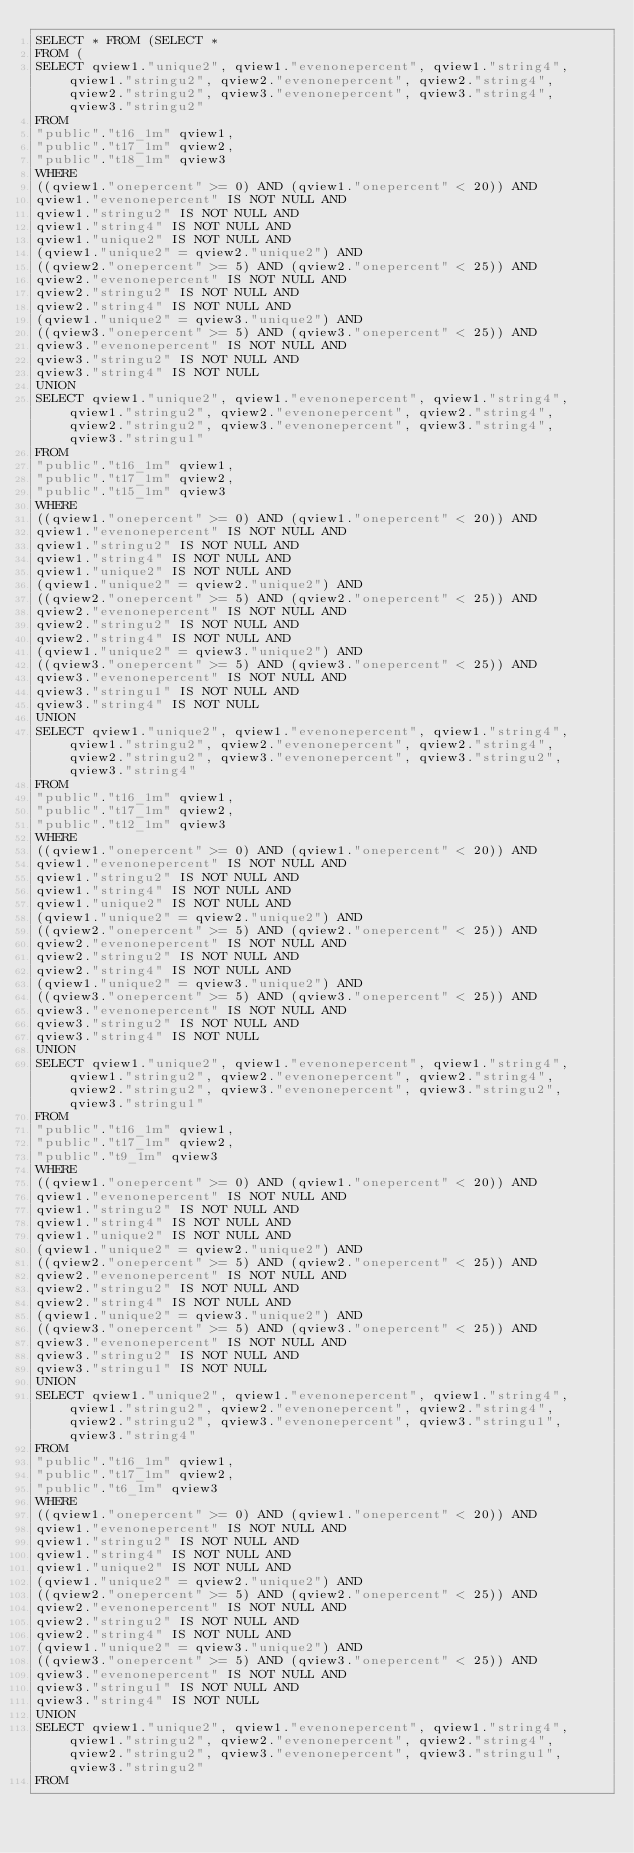Convert code to text. <code><loc_0><loc_0><loc_500><loc_500><_SQL_>SELECT * FROM (SELECT *
FROM (
SELECT qview1."unique2", qview1."evenonepercent", qview1."string4", qview1."stringu2", qview2."evenonepercent", qview2."string4", qview2."stringu2", qview3."evenonepercent", qview3."string4", qview3."stringu2"
FROM
"public"."t16_1m" qview1,
"public"."t17_1m" qview2,
"public"."t18_1m" qview3
WHERE
((qview1."onepercent" >= 0) AND (qview1."onepercent" < 20)) AND
qview1."evenonepercent" IS NOT NULL AND
qview1."stringu2" IS NOT NULL AND
qview1."string4" IS NOT NULL AND
qview1."unique2" IS NOT NULL AND
(qview1."unique2" = qview2."unique2") AND
((qview2."onepercent" >= 5) AND (qview2."onepercent" < 25)) AND
qview2."evenonepercent" IS NOT NULL AND
qview2."stringu2" IS NOT NULL AND
qview2."string4" IS NOT NULL AND
(qview1."unique2" = qview3."unique2") AND
((qview3."onepercent" >= 5) AND (qview3."onepercent" < 25)) AND
qview3."evenonepercent" IS NOT NULL AND
qview3."stringu2" IS NOT NULL AND
qview3."string4" IS NOT NULL
UNION
SELECT qview1."unique2", qview1."evenonepercent", qview1."string4", qview1."stringu2", qview2."evenonepercent", qview2."string4", qview2."stringu2", qview3."evenonepercent", qview3."string4", qview3."stringu1"
FROM
"public"."t16_1m" qview1,
"public"."t17_1m" qview2,
"public"."t15_1m" qview3
WHERE
((qview1."onepercent" >= 0) AND (qview1."onepercent" < 20)) AND
qview1."evenonepercent" IS NOT NULL AND
qview1."stringu2" IS NOT NULL AND
qview1."string4" IS NOT NULL AND
qview1."unique2" IS NOT NULL AND
(qview1."unique2" = qview2."unique2") AND
((qview2."onepercent" >= 5) AND (qview2."onepercent" < 25)) AND
qview2."evenonepercent" IS NOT NULL AND
qview2."stringu2" IS NOT NULL AND
qview2."string4" IS NOT NULL AND
(qview1."unique2" = qview3."unique2") AND
((qview3."onepercent" >= 5) AND (qview3."onepercent" < 25)) AND
qview3."evenonepercent" IS NOT NULL AND
qview3."stringu1" IS NOT NULL AND
qview3."string4" IS NOT NULL
UNION
SELECT qview1."unique2", qview1."evenonepercent", qview1."string4", qview1."stringu2", qview2."evenonepercent", qview2."string4", qview2."stringu2", qview3."evenonepercent", qview3."stringu2", qview3."string4"
FROM
"public"."t16_1m" qview1,
"public"."t17_1m" qview2,
"public"."t12_1m" qview3
WHERE
((qview1."onepercent" >= 0) AND (qview1."onepercent" < 20)) AND
qview1."evenonepercent" IS NOT NULL AND
qview1."stringu2" IS NOT NULL AND
qview1."string4" IS NOT NULL AND
qview1."unique2" IS NOT NULL AND
(qview1."unique2" = qview2."unique2") AND
((qview2."onepercent" >= 5) AND (qview2."onepercent" < 25)) AND
qview2."evenonepercent" IS NOT NULL AND
qview2."stringu2" IS NOT NULL AND
qview2."string4" IS NOT NULL AND
(qview1."unique2" = qview3."unique2") AND
((qview3."onepercent" >= 5) AND (qview3."onepercent" < 25)) AND
qview3."evenonepercent" IS NOT NULL AND
qview3."stringu2" IS NOT NULL AND
qview3."string4" IS NOT NULL
UNION
SELECT qview1."unique2", qview1."evenonepercent", qview1."string4", qview1."stringu2", qview2."evenonepercent", qview2."string4", qview2."stringu2", qview3."evenonepercent", qview3."stringu2", qview3."stringu1"
FROM
"public"."t16_1m" qview1,
"public"."t17_1m" qview2,
"public"."t9_1m" qview3
WHERE
((qview1."onepercent" >= 0) AND (qview1."onepercent" < 20)) AND
qview1."evenonepercent" IS NOT NULL AND
qview1."stringu2" IS NOT NULL AND
qview1."string4" IS NOT NULL AND
qview1."unique2" IS NOT NULL AND
(qview1."unique2" = qview2."unique2") AND
((qview2."onepercent" >= 5) AND (qview2."onepercent" < 25)) AND
qview2."evenonepercent" IS NOT NULL AND
qview2."stringu2" IS NOT NULL AND
qview2."string4" IS NOT NULL AND
(qview1."unique2" = qview3."unique2") AND
((qview3."onepercent" >= 5) AND (qview3."onepercent" < 25)) AND
qview3."evenonepercent" IS NOT NULL AND
qview3."stringu2" IS NOT NULL AND
qview3."stringu1" IS NOT NULL
UNION
SELECT qview1."unique2", qview1."evenonepercent", qview1."string4", qview1."stringu2", qview2."evenonepercent", qview2."string4", qview2."stringu2", qview3."evenonepercent", qview3."stringu1", qview3."string4"
FROM
"public"."t16_1m" qview1,
"public"."t17_1m" qview2,
"public"."t6_1m" qview3
WHERE
((qview1."onepercent" >= 0) AND (qview1."onepercent" < 20)) AND
qview1."evenonepercent" IS NOT NULL AND
qview1."stringu2" IS NOT NULL AND
qview1."string4" IS NOT NULL AND
qview1."unique2" IS NOT NULL AND
(qview1."unique2" = qview2."unique2") AND
((qview2."onepercent" >= 5) AND (qview2."onepercent" < 25)) AND
qview2."evenonepercent" IS NOT NULL AND
qview2."stringu2" IS NOT NULL AND
qview2."string4" IS NOT NULL AND
(qview1."unique2" = qview3."unique2") AND
((qview3."onepercent" >= 5) AND (qview3."onepercent" < 25)) AND
qview3."evenonepercent" IS NOT NULL AND
qview3."stringu1" IS NOT NULL AND
qview3."string4" IS NOT NULL
UNION
SELECT qview1."unique2", qview1."evenonepercent", qview1."string4", qview1."stringu2", qview2."evenonepercent", qview2."string4", qview2."stringu2", qview3."evenonepercent", qview3."stringu1", qview3."stringu2"
FROM</code> 